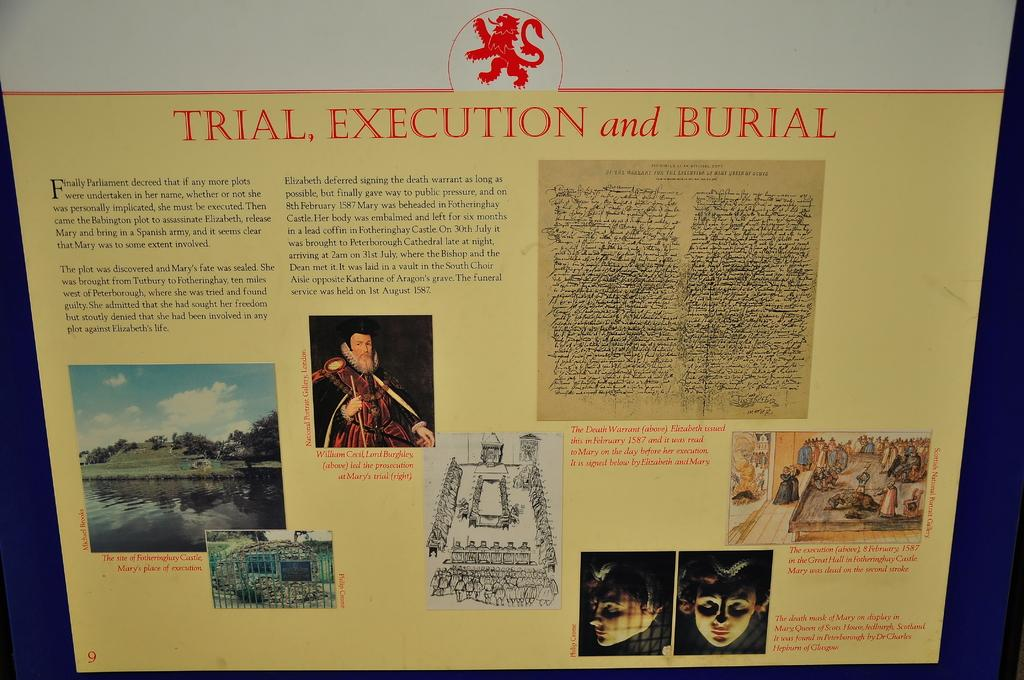<image>
Summarize the visual content of the image. A poster sized report on the trial, execution, and burial of a historic person named Mary. 